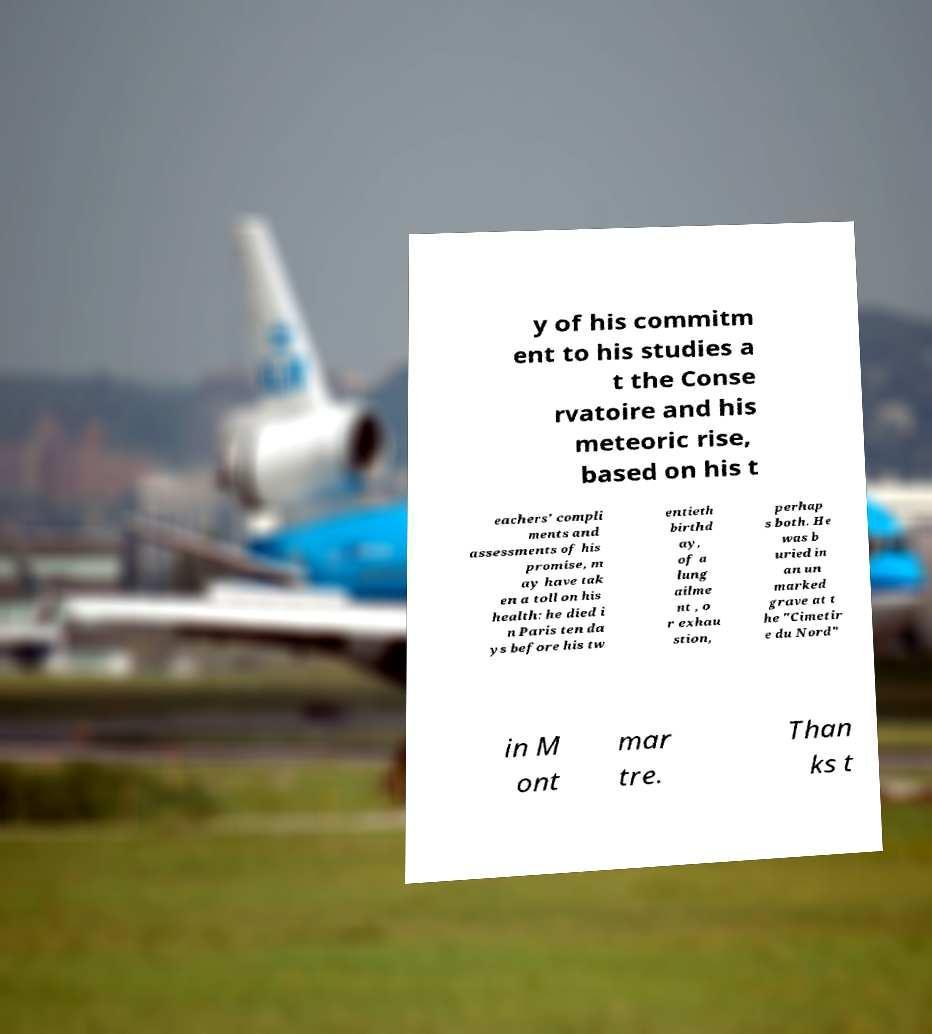For documentation purposes, I need the text within this image transcribed. Could you provide that? y of his commitm ent to his studies a t the Conse rvatoire and his meteoric rise, based on his t eachers' compli ments and assessments of his promise, m ay have tak en a toll on his health: he died i n Paris ten da ys before his tw entieth birthd ay, of a lung ailme nt , o r exhau stion, perhap s both. He was b uried in an un marked grave at t he "Cimetir e du Nord" in M ont mar tre. Than ks t 